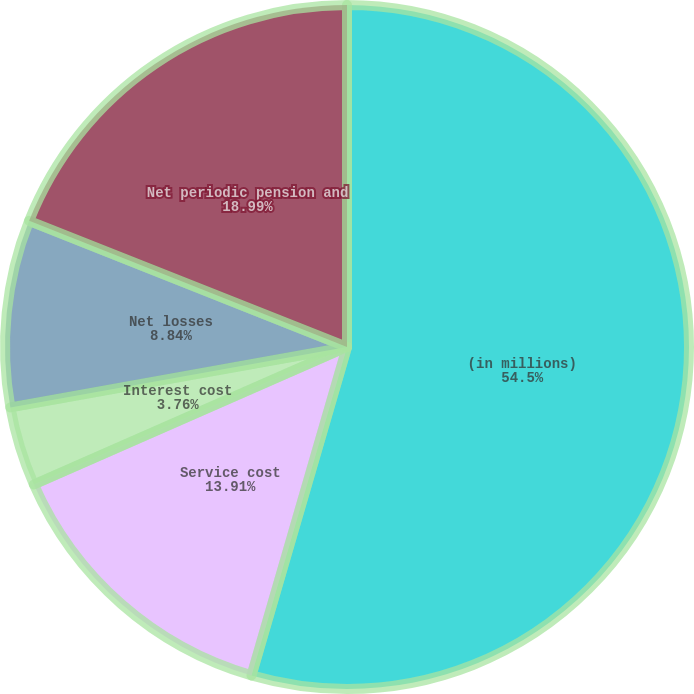<chart> <loc_0><loc_0><loc_500><loc_500><pie_chart><fcel>(in millions)<fcel>Service cost<fcel>Interest cost<fcel>Net losses<fcel>Net periodic pension and<nl><fcel>54.51%<fcel>13.91%<fcel>3.76%<fcel>8.84%<fcel>18.99%<nl></chart> 